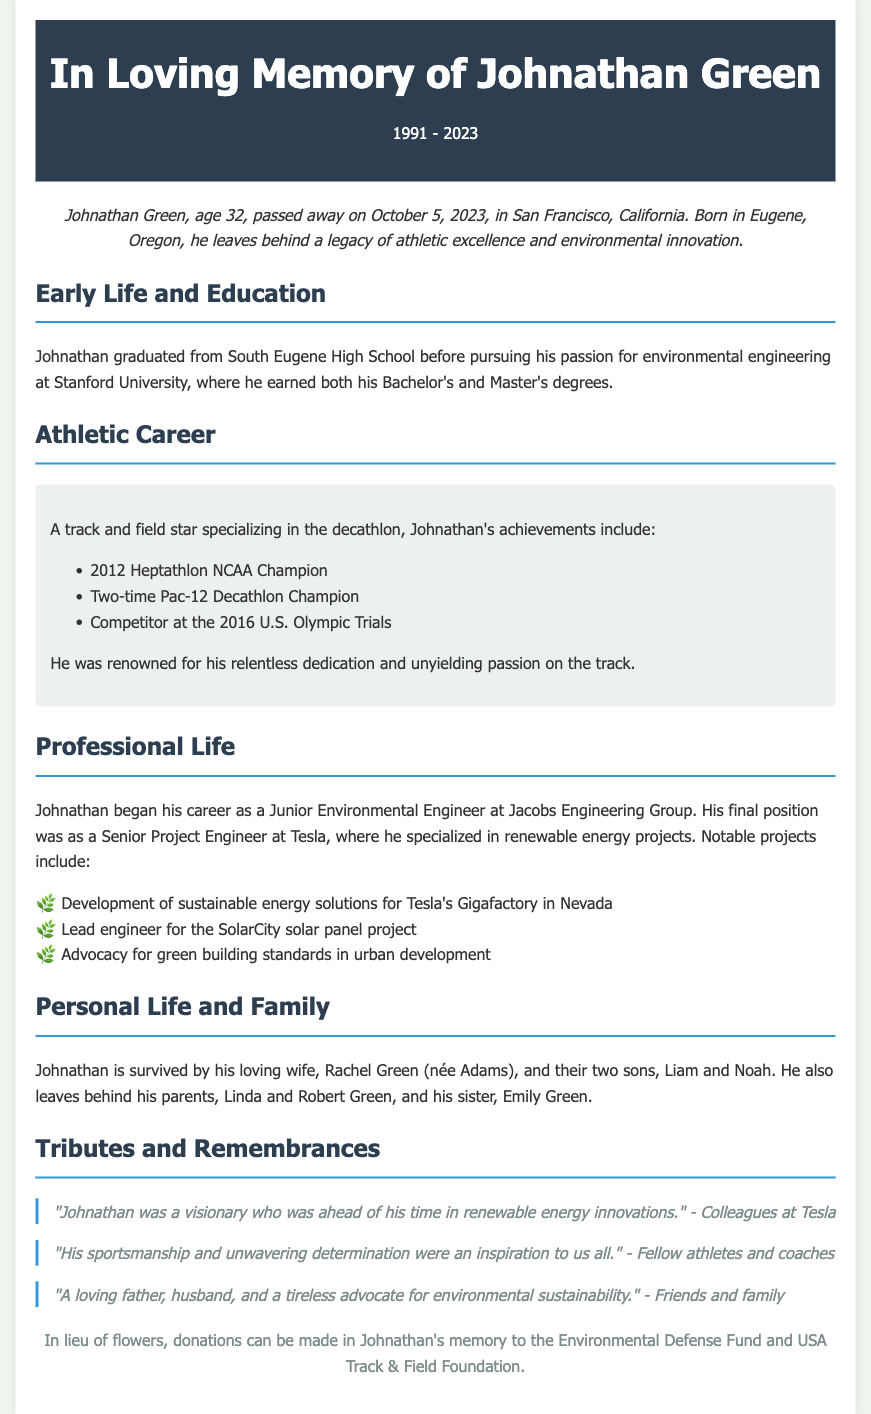What was Johnathan Green's age at the time of his passing? The document states that Johnathan Green passed away at the age of 32.
Answer: 32 When did Johnathan graduate from Stanford University? The document does not specify the exact year of his graduation, but it says he pursued his Bachelor's and Master's degrees there.
Answer: Not specified What sport did Johnathan excel in? The document mentions that he was a star in track and field, specializing in the decathlon.
Answer: Decathlon What is one of the notable projects Johnathan worked on at Tesla? The document lists sustainable energy solutions for Tesla's Gigafactory in Nevada as one of his notable projects.
Answer: Gigafactory in Nevada Who is Johnathan survived by? The document states he is survived by his wife Rachel and their two sons, Liam and Noah.
Answer: Rachel, Liam, and Noah What was Johnathan's final position before his passing? The document states that his final position was as a Senior Project Engineer at Tesla.
Answer: Senior Project Engineer at Tesla What was one of the tributes mentioned about Johnathan? The document contains a tribute stating he was a visionary in renewable energy innovations according to his colleagues at Tesla.
Answer: A visionary Why might Johnathan's achievements in sports matter in relation to his career? The document links his relentless dedication and unyielding passion in sports to his professional success as an environmental engineer.
Answer: Dedication and passion What can be done in lieu of flowers? The document mentions that donations can be made in Johnathan's memory to specific organizations instead of flowers.
Answer: Donations to Environmental Defense Fund and USA Track & Field Foundation 